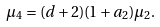Convert formula to latex. <formula><loc_0><loc_0><loc_500><loc_500>\mu _ { 4 } = ( d + 2 ) ( 1 + a _ { 2 } ) \mu _ { 2 } .</formula> 